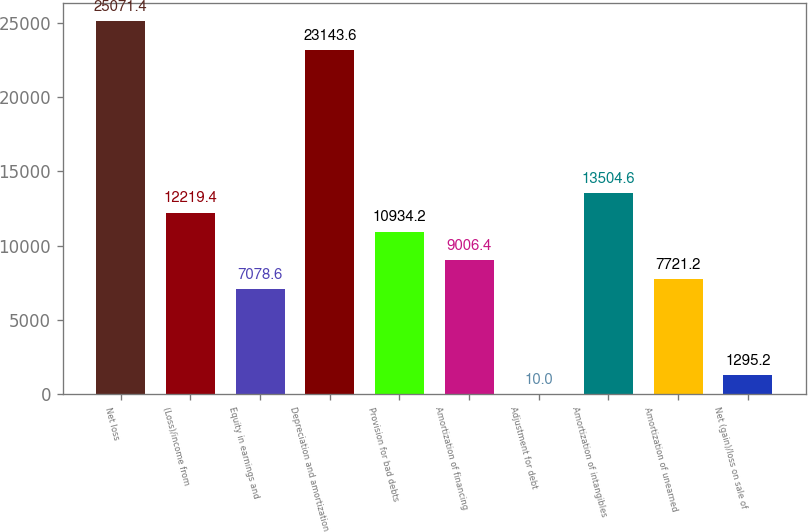Convert chart. <chart><loc_0><loc_0><loc_500><loc_500><bar_chart><fcel>Net loss<fcel>(Loss)/income from<fcel>Equity in earnings and<fcel>Depreciation and amortization<fcel>Provision for bad debts<fcel>Amortization of financing<fcel>Adjustment for debt<fcel>Amortization of intangibles<fcel>Amortization of unearned<fcel>Net (gain)/loss on sale of<nl><fcel>25071.4<fcel>12219.4<fcel>7078.6<fcel>23143.6<fcel>10934.2<fcel>9006.4<fcel>10<fcel>13504.6<fcel>7721.2<fcel>1295.2<nl></chart> 